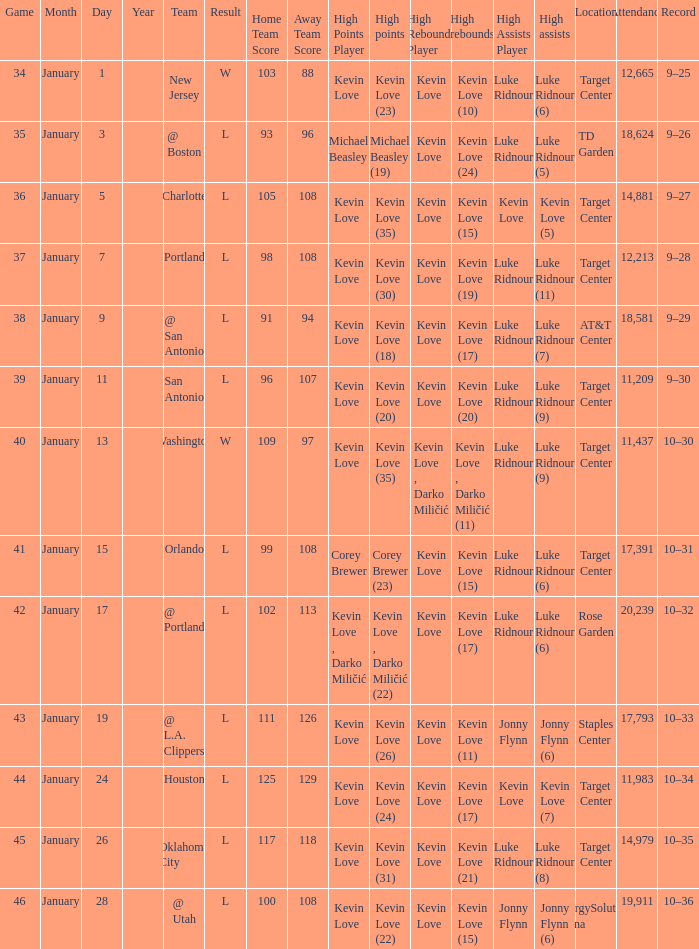Would you mind parsing the complete table? {'header': ['Game', 'Month', 'Day', 'Year', 'Team', 'Result', 'Home Team Score', 'Away Team Score', 'High Points Player', 'High points', 'High Rebounds Player', 'High rebounds', 'High Assists Player', 'High assists', 'Location', 'Attendance', 'Record'], 'rows': [['34', 'January', '1', '', 'New Jersey', 'W', '103', '88', 'Kevin Love', 'Kevin Love (23)', 'Kevin Love', 'Kevin Love (10)', 'Luke Ridnour', 'Luke Ridnour (6)', 'Target Center', '12,665', '9–25'], ['35', 'January', '3', '', '@ Boston', 'L', '93', '96', 'Michael Beasley', 'Michael Beasley (19)', 'Kevin Love', 'Kevin Love (24)', 'Luke Ridnour', 'Luke Ridnour (5)', 'TD Garden', '18,624', '9–26'], ['36', 'January', '5', '', 'Charlotte', 'L', '105', '108', 'Kevin Love', 'Kevin Love (35)', 'Kevin Love', 'Kevin Love (15)', 'Kevin Love', 'Kevin Love (5)', 'Target Center', '14,881', '9–27'], ['37', 'January', '7', '', 'Portland', 'L', '98', '108', 'Kevin Love', 'Kevin Love (30)', 'Kevin Love', 'Kevin Love (19)', 'Luke Ridnour', 'Luke Ridnour (11)', 'Target Center', '12,213', '9–28'], ['38', 'January', '9', '', '@ San Antonio', 'L', '91', '94', 'Kevin Love', 'Kevin Love (18)', 'Kevin Love', 'Kevin Love (17)', 'Luke Ridnour', 'Luke Ridnour (7)', 'AT&T Center', '18,581', '9–29'], ['39', 'January', '11', '', 'San Antonio', 'L', '96', '107', 'Kevin Love', 'Kevin Love (20)', 'Kevin Love', 'Kevin Love (20)', 'Luke Ridnour', 'Luke Ridnour (9)', 'Target Center', '11,209', '9–30'], ['40', 'January', '13', '', 'Washington', 'W', '109', '97', 'Kevin Love', 'Kevin Love (35)', 'Kevin Love , Darko Miličić', 'Kevin Love , Darko Miličić (11)', 'Luke Ridnour', 'Luke Ridnour (9)', 'Target Center', '11,437', '10–30'], ['41', 'January', '15', '', 'Orlando', 'L', '99', '108', 'Corey Brewer', 'Corey Brewer (23)', 'Kevin Love', 'Kevin Love (15)', 'Luke Ridnour', 'Luke Ridnour (6)', 'Target Center', '17,391', '10–31'], ['42', 'January', '17', '', '@ Portland', 'L', '102', '113', 'Kevin Love , Darko Miličić', 'Kevin Love , Darko Miličić (22)', 'Kevin Love', 'Kevin Love (17)', 'Luke Ridnour', 'Luke Ridnour (6)', 'Rose Garden', '20,239', '10–32'], ['43', 'January', '19', '', '@ L.A. Clippers', 'L', '111', '126', 'Kevin Love', 'Kevin Love (26)', 'Kevin Love', 'Kevin Love (11)', 'Jonny Flynn', 'Jonny Flynn (6)', 'Staples Center', '17,793', '10–33'], ['44', 'January', '24', '', 'Houston', 'L', '125', '129', 'Kevin Love', 'Kevin Love (24)', 'Kevin Love', 'Kevin Love (17)', 'Kevin Love', 'Kevin Love (7)', 'Target Center', '11,983', '10–34'], ['45', 'January', '26', '', 'Oklahoma City', 'L', '117', '118', 'Kevin Love', 'Kevin Love (31)', 'Kevin Love', 'Kevin Love (21)', 'Luke Ridnour', 'Luke Ridnour (8)', 'Target Center', '14,979', '10–35'], ['46', 'January', '28', '', '@ Utah', 'L', '100', '108', 'Kevin Love', 'Kevin Love (22)', 'Kevin Love', 'Kevin Love (15)', 'Jonny Flynn', 'Jonny Flynn (6)', 'EnergySolutions Arena', '19,911', '10–36']]} How many times did kevin love (22) have the high points? 1.0. 